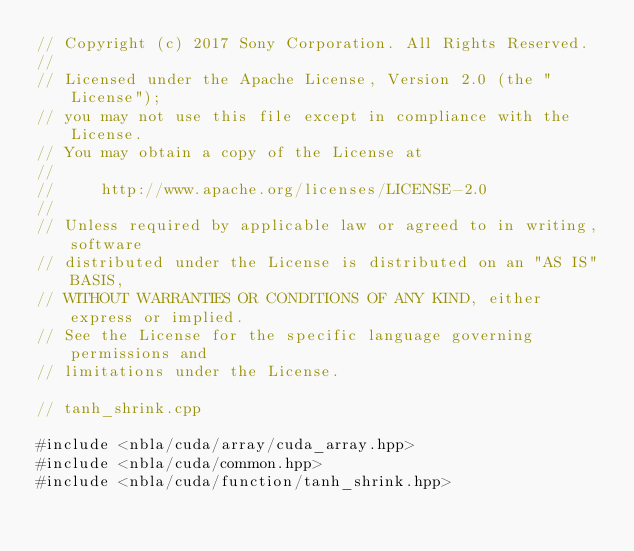<code> <loc_0><loc_0><loc_500><loc_500><_Cuda_>// Copyright (c) 2017 Sony Corporation. All Rights Reserved.
//
// Licensed under the Apache License, Version 2.0 (the "License");
// you may not use this file except in compliance with the License.
// You may obtain a copy of the License at
//
//     http://www.apache.org/licenses/LICENSE-2.0
//
// Unless required by applicable law or agreed to in writing, software
// distributed under the License is distributed on an "AS IS" BASIS,
// WITHOUT WARRANTIES OR CONDITIONS OF ANY KIND, either express or implied.
// See the License for the specific language governing permissions and
// limitations under the License.

// tanh_shrink.cpp

#include <nbla/cuda/array/cuda_array.hpp>
#include <nbla/cuda/common.hpp>
#include <nbla/cuda/function/tanh_shrink.hpp></code> 